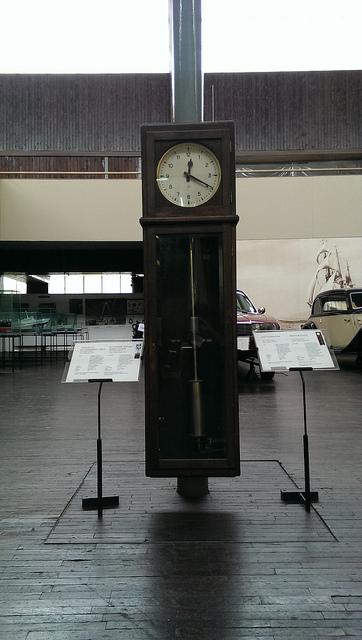What kind of stands are on either side of the clock?
Give a very brief answer. Music. What is the clock tower made out of?
Keep it brief. Wood. Is the clock floating?
Concise answer only. No. 